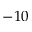Convert formula to latex. <formula><loc_0><loc_0><loc_500><loc_500>- 1 0</formula> 